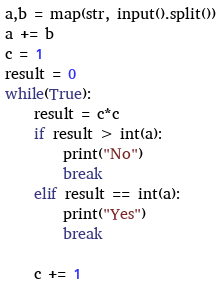<code> <loc_0><loc_0><loc_500><loc_500><_Python_>a,b = map(str, input().split())
a += b
c = 1
result = 0
while(True):
    result = c*c
    if result > int(a):
        print("No")
        break
    elif result == int(a):
        print("Yes")
        break

    c += 1
</code> 